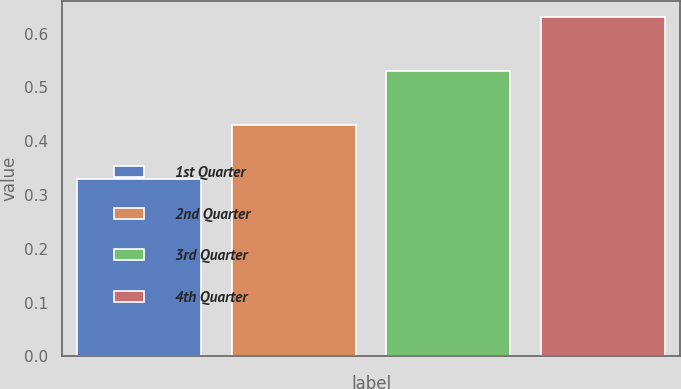<chart> <loc_0><loc_0><loc_500><loc_500><bar_chart><fcel>1st Quarter<fcel>2nd Quarter<fcel>3rd Quarter<fcel>4th Quarter<nl><fcel>0.33<fcel>0.43<fcel>0.53<fcel>0.63<nl></chart> 